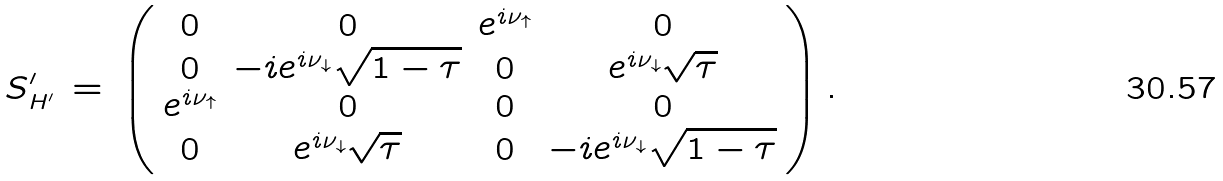<formula> <loc_0><loc_0><loc_500><loc_500>S ^ { \prime } _ { H ^ { \prime } } \, = \, \left ( \begin{array} { c c c c } 0 & 0 & e ^ { i \nu _ { \uparrow } } & 0 \\ 0 & - i e ^ { i \nu _ { \downarrow } } \sqrt { 1 - \tau } & 0 & e ^ { i \nu _ { \downarrow } } \sqrt { \tau } \\ e ^ { i \nu _ { \uparrow } } & 0 & 0 & 0 \\ 0 & e ^ { i \nu _ { \downarrow } } \sqrt { \tau } & 0 & - i e ^ { i \nu _ { \downarrow } } \sqrt { 1 - \tau } \end{array} \right ) .</formula> 